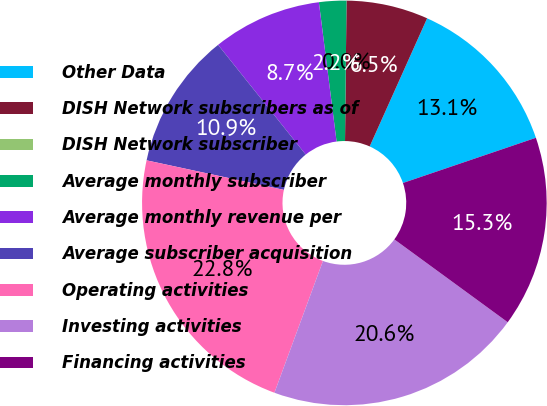Convert chart to OTSL. <chart><loc_0><loc_0><loc_500><loc_500><pie_chart><fcel>Other Data<fcel>DISH Network subscribers as of<fcel>DISH Network subscriber<fcel>Average monthly subscriber<fcel>Average monthly revenue per<fcel>Average subscriber acquisition<fcel>Operating activities<fcel>Investing activities<fcel>Financing activities<nl><fcel>13.08%<fcel>6.54%<fcel>0.0%<fcel>2.18%<fcel>8.72%<fcel>10.9%<fcel>22.76%<fcel>20.58%<fcel>15.26%<nl></chart> 